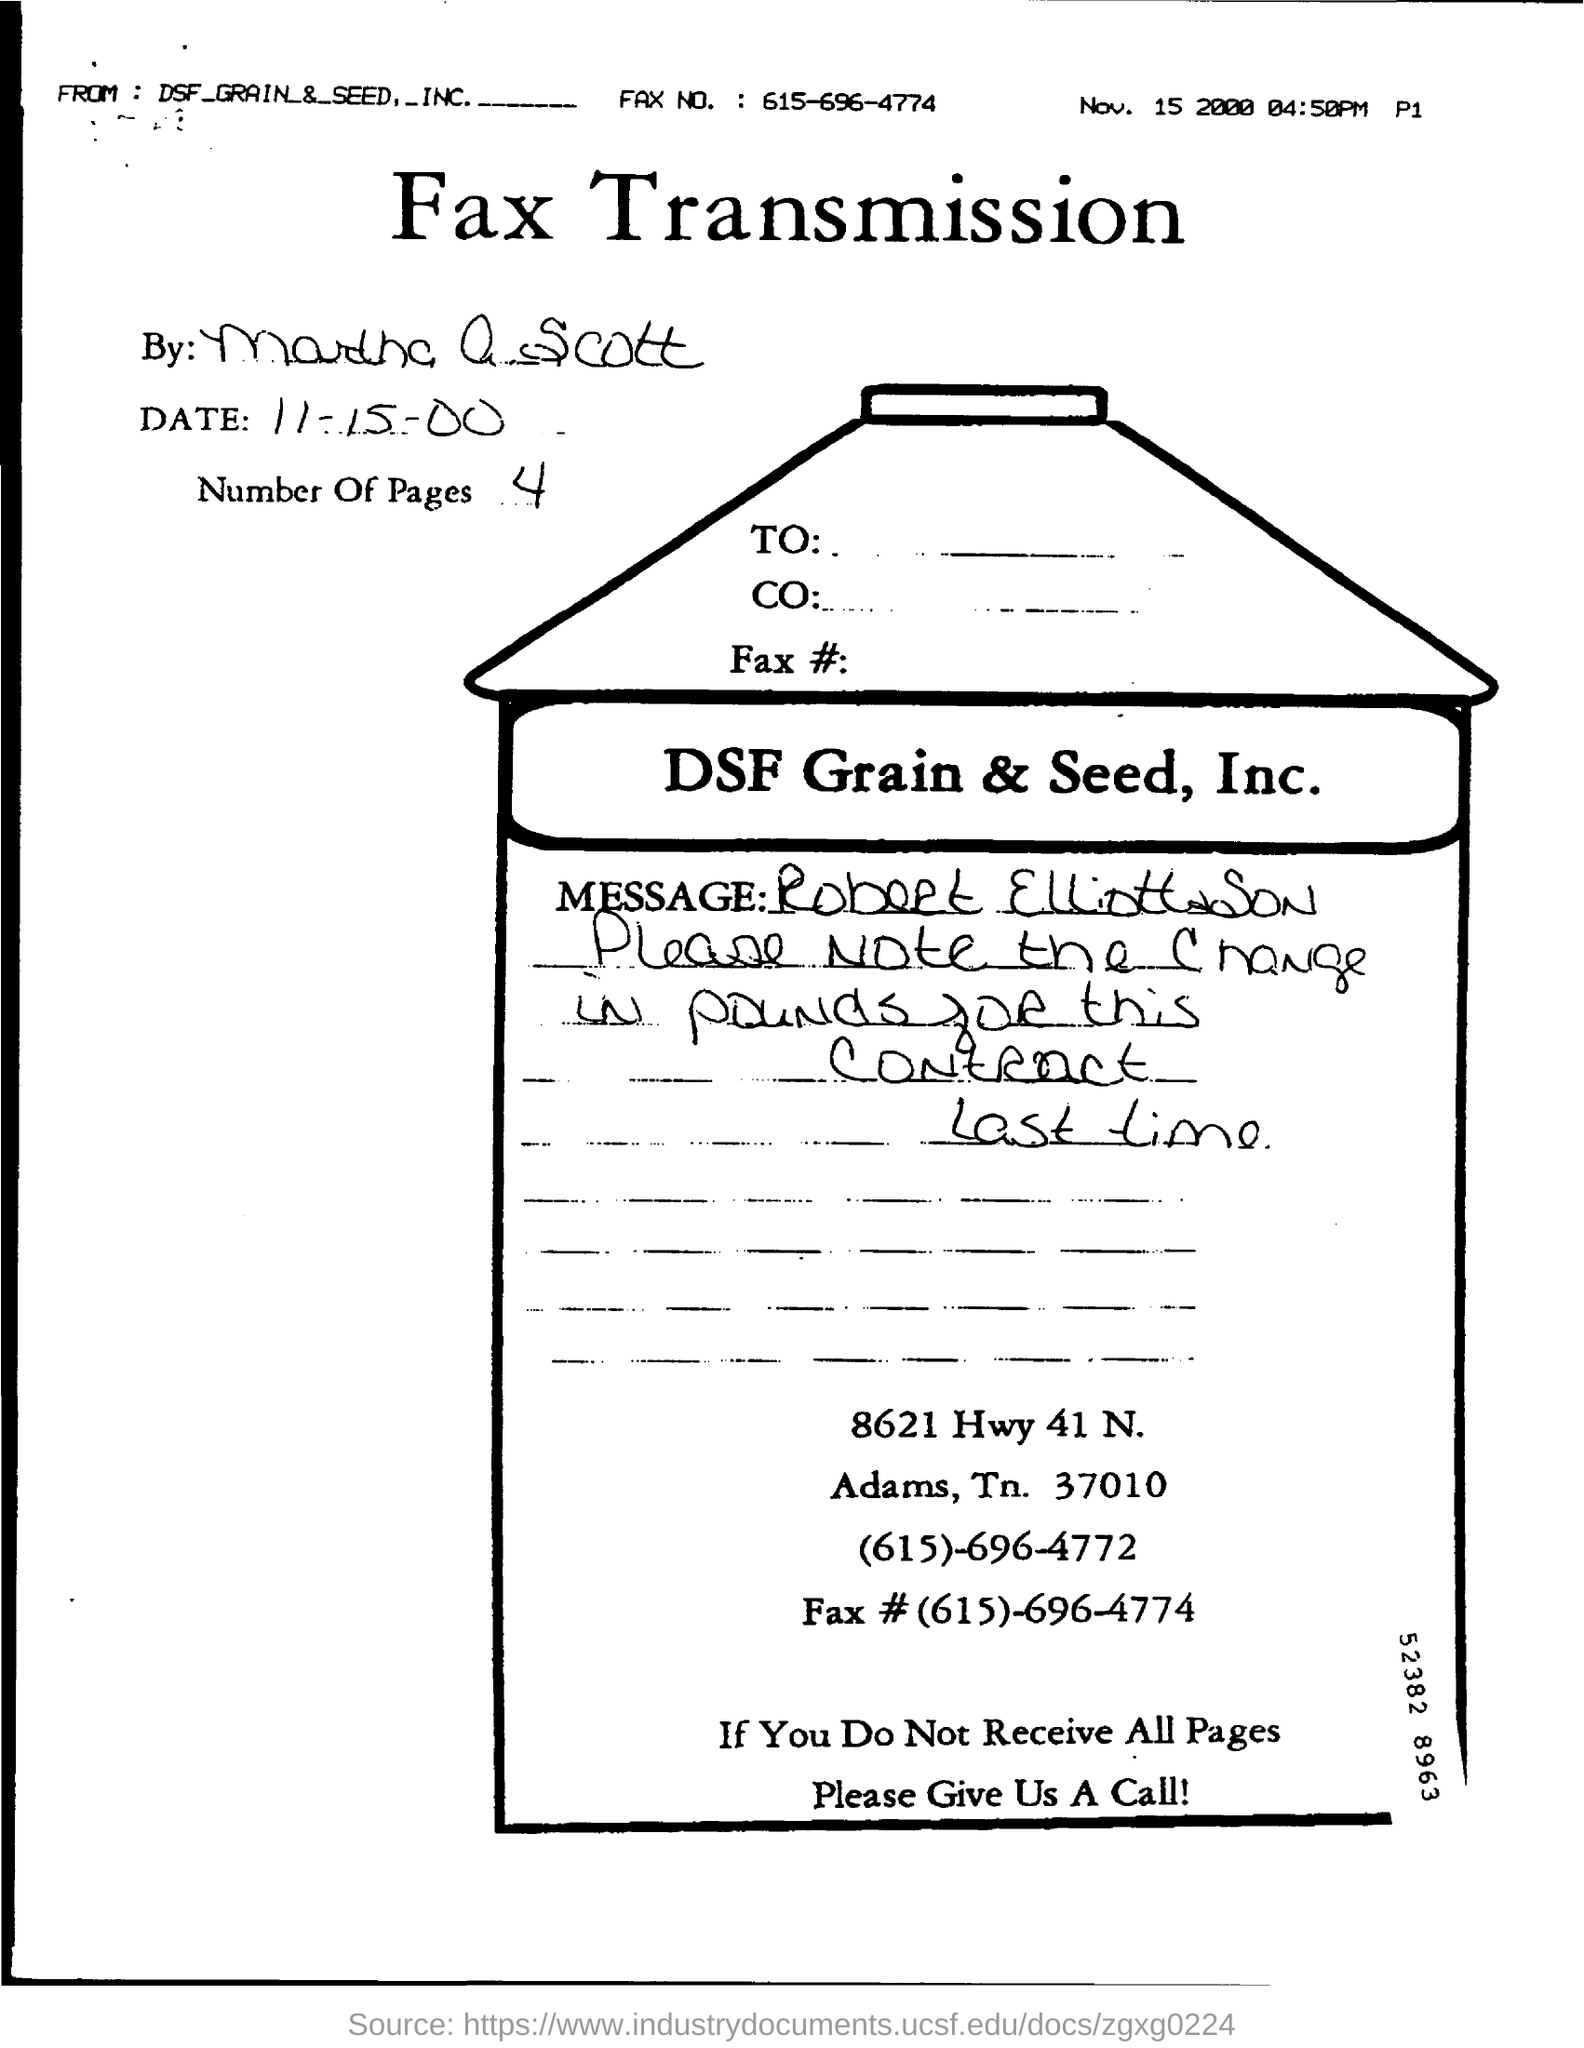What type of communication is this?
Offer a very short reply. Fax Transmission. What is the number of pages in the fax?
Offer a terse response. 4. What is the date of fax transmission?
Offer a very short reply. 11-15-00. What is the no of pages in the fax?
Offer a very short reply. 4. What is the FAX no mentioned here?
Make the answer very short. (615)-696-4774. 